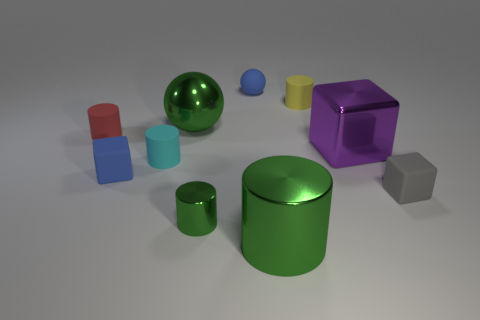There is a small cylinder that is the same color as the large sphere; what material is it?
Offer a very short reply. Metal. Do the small yellow rubber thing and the large purple shiny thing have the same shape?
Provide a succinct answer. No. What number of other things are there of the same size as the shiny ball?
Your answer should be very brief. 2. What is the color of the shiny sphere?
Make the answer very short. Green. How many tiny objects are either green rubber cubes or green objects?
Provide a short and direct response. 1. Is the size of the green shiny object that is behind the small gray object the same as the blue rubber object that is to the right of the big ball?
Your answer should be compact. No. What is the size of the blue object that is the same shape as the gray thing?
Your answer should be very brief. Small. Is the number of large green spheres on the right side of the gray matte block greater than the number of balls that are in front of the cyan rubber cylinder?
Your answer should be very brief. No. What is the material of the tiny object that is both on the right side of the small green object and in front of the yellow matte cylinder?
Ensure brevity in your answer.  Rubber. What is the color of the large shiny thing that is the same shape as the small gray object?
Make the answer very short. Purple. 